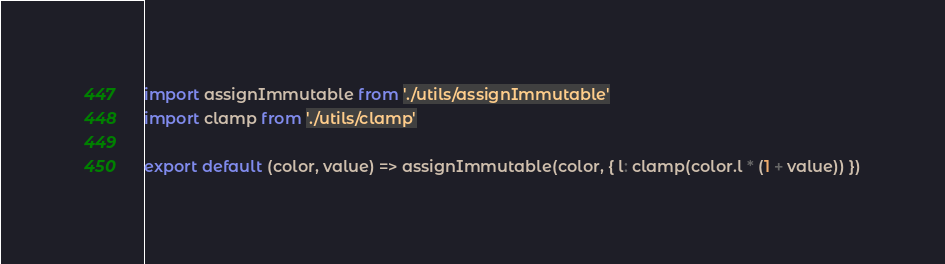Convert code to text. <code><loc_0><loc_0><loc_500><loc_500><_JavaScript_>import assignImmutable from './utils/assignImmutable'
import clamp from './utils/clamp'

export default (color, value) => assignImmutable(color, { l: clamp(color.l * (1 + value)) })
</code> 